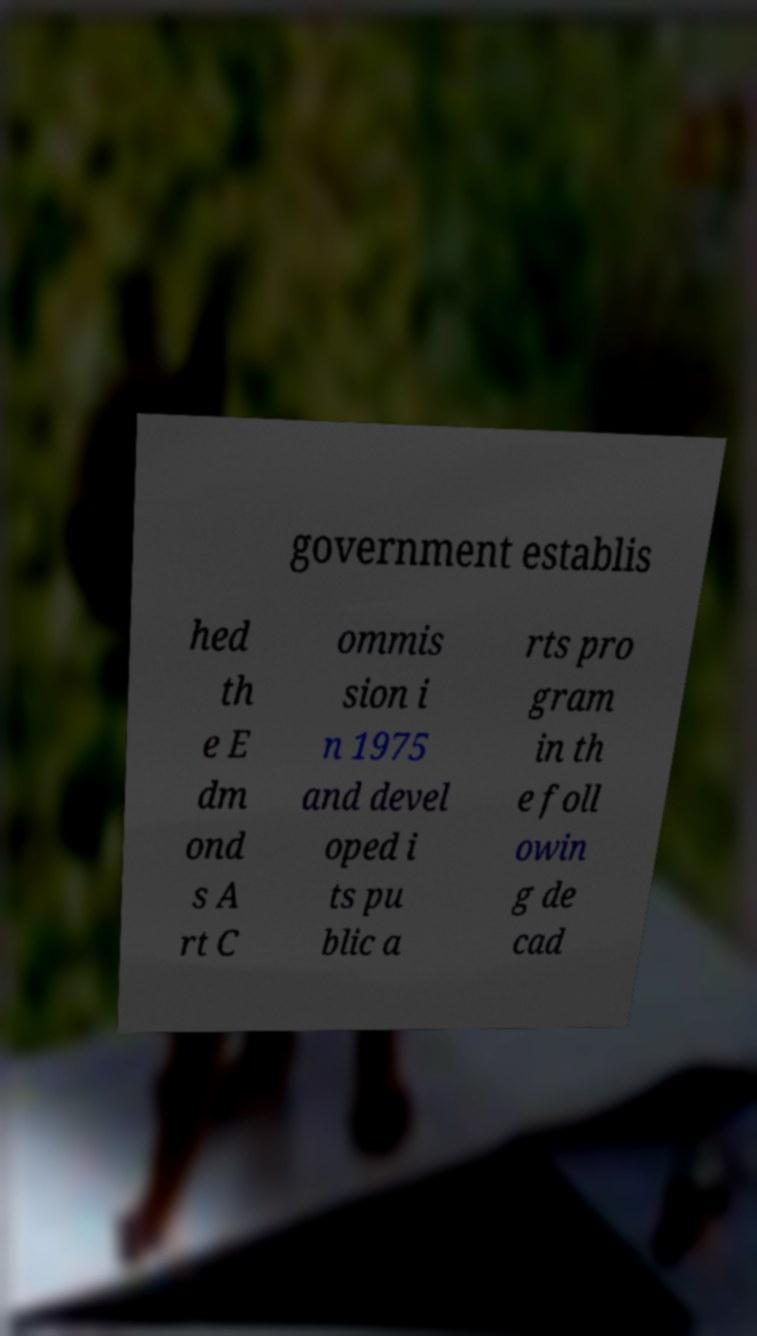Please read and relay the text visible in this image. What does it say? government establis hed th e E dm ond s A rt C ommis sion i n 1975 and devel oped i ts pu blic a rts pro gram in th e foll owin g de cad 